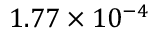Convert formula to latex. <formula><loc_0><loc_0><loc_500><loc_500>1 . 7 7 \times 1 0 ^ { - 4 }</formula> 